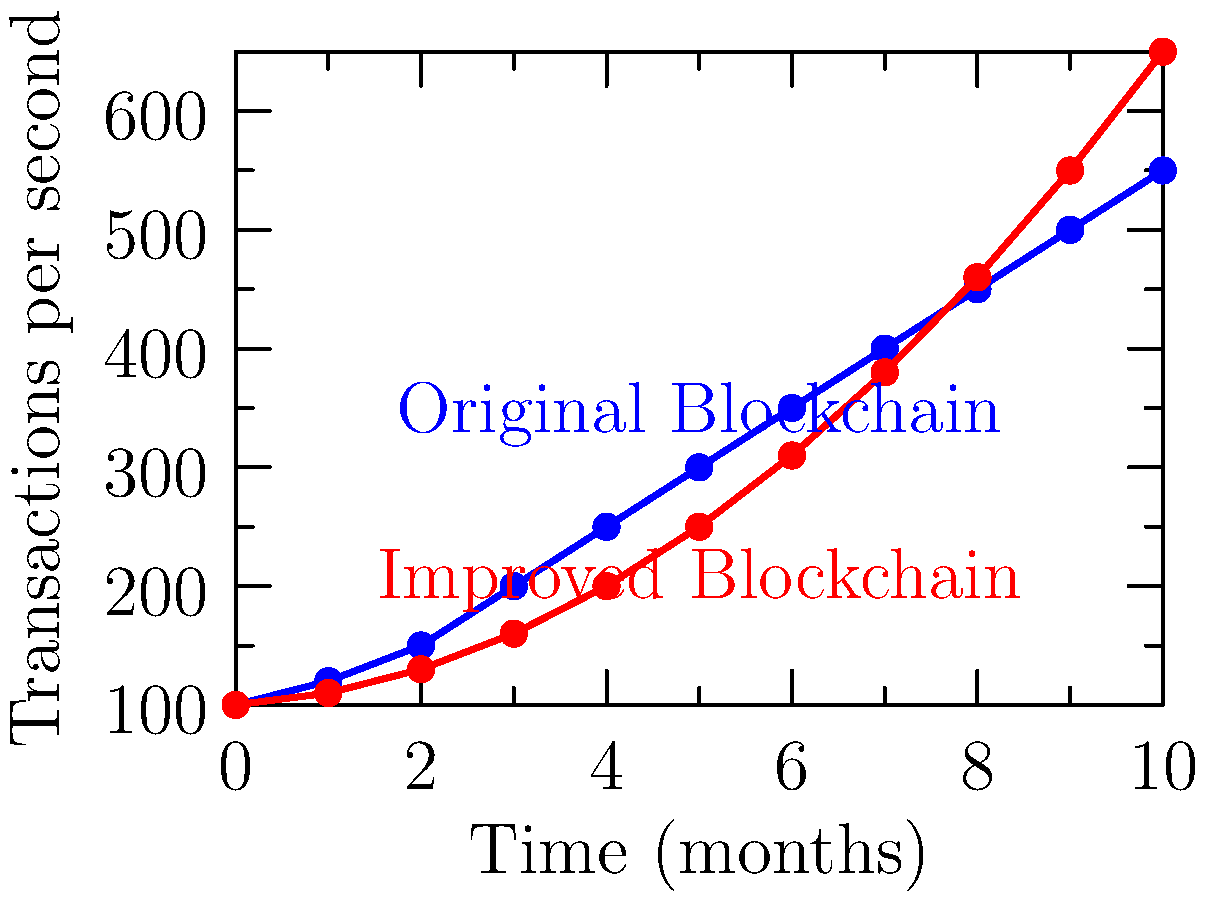Given the line graph showing blockchain transaction throughput over time for an original blockchain and an improved version, calculate the percentage increase in transaction throughput from month 0 to month 10 for the improved blockchain. Round your answer to the nearest whole percentage. To calculate the percentage increase in transaction throughput for the improved blockchain from month 0 to month 10, we'll follow these steps:

1. Identify the initial (month 0) throughput value for the improved blockchain:
   Initial value = 100 transactions per second

2. Identify the final (month 10) throughput value for the improved blockchain:
   Final value = 650 transactions per second

3. Calculate the absolute increase:
   Increase = Final value - Initial value
   Increase = 650 - 100 = 550 transactions per second

4. Calculate the percentage increase:
   Percentage increase = (Increase / Initial value) * 100
   Percentage increase = (550 / 100) * 100 = 550%

5. Round to the nearest whole percentage:
   550% (no rounding needed in this case)

Therefore, the percentage increase in transaction throughput for the improved blockchain from month 0 to month 10 is 550%.
Answer: 550% 